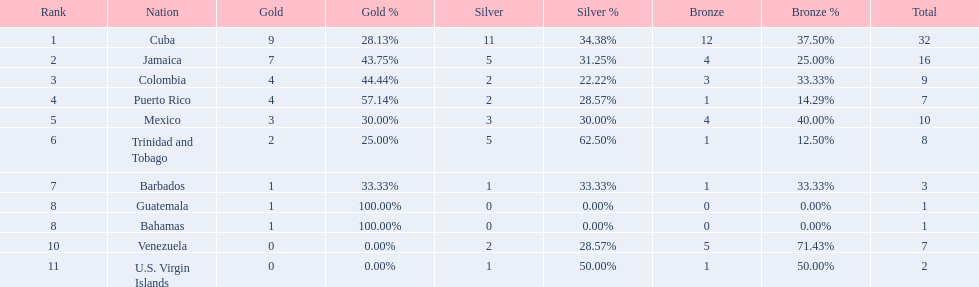Which 3 countries were awarded the most medals? Cuba, Jamaica, Colombia. Of these 3 countries which ones are islands? Cuba, Jamaica. Which one won the most silver medals? Cuba. 